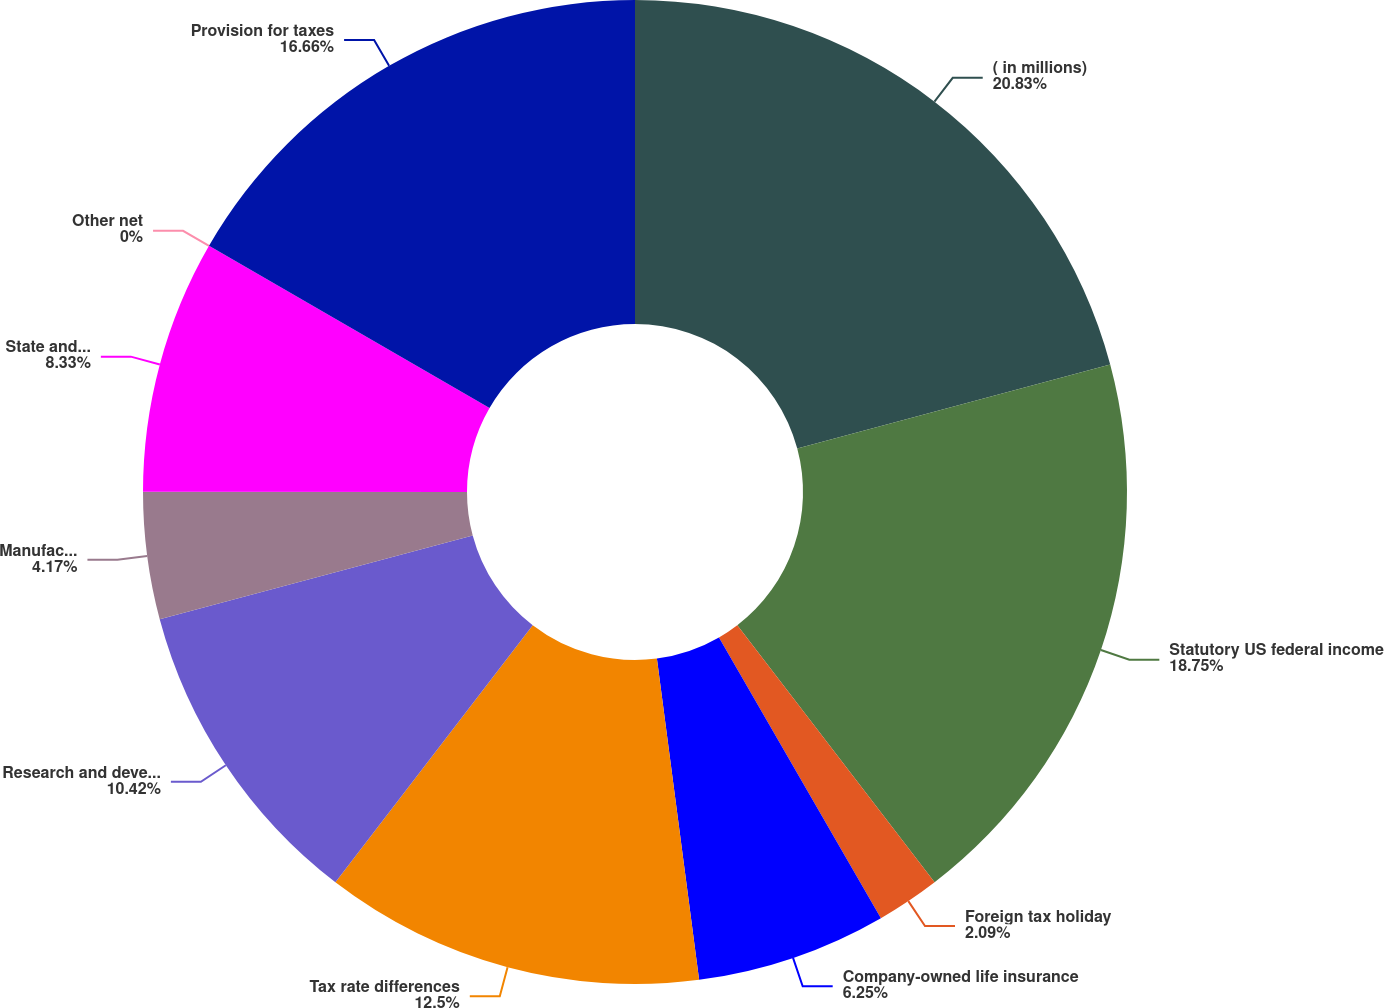Convert chart. <chart><loc_0><loc_0><loc_500><loc_500><pie_chart><fcel>( in millions)<fcel>Statutory US federal income<fcel>Foreign tax holiday<fcel>Company-owned life insurance<fcel>Tax rate differences<fcel>Research and development tax<fcel>Manufacturing deduction<fcel>State and local taxes net<fcel>Other net<fcel>Provision for taxes<nl><fcel>20.83%<fcel>18.75%<fcel>2.09%<fcel>6.25%<fcel>12.5%<fcel>10.42%<fcel>4.17%<fcel>8.33%<fcel>0.0%<fcel>16.66%<nl></chart> 